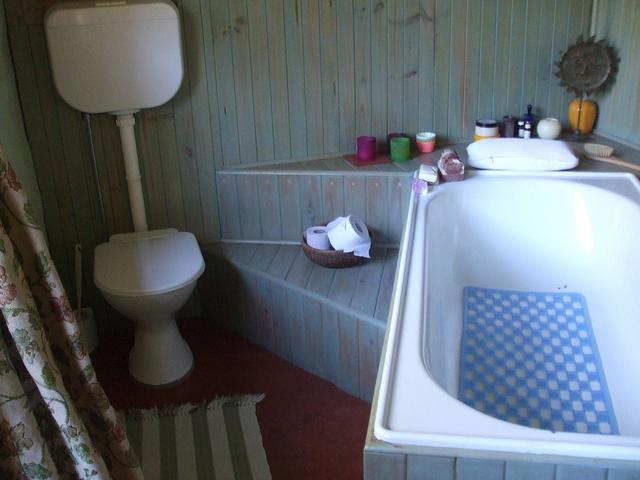What type of rolls are in the wicker basket?

Choices:
A) jelly
B) toilet
C) camera
D) dinner toilet 